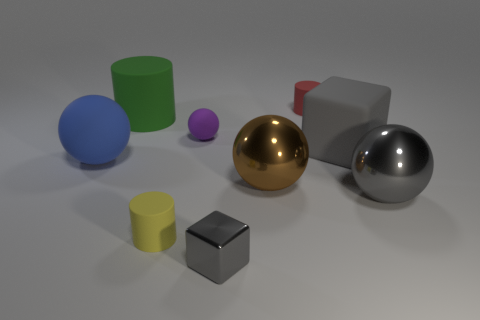Subtract all blue cylinders. Subtract all yellow balls. How many cylinders are left? 3 Subtract all green spheres. How many brown cylinders are left? 0 Add 4 greens. How many purples exist? 0 Subtract all big brown cylinders. Subtract all blue rubber spheres. How many objects are left? 8 Add 5 matte balls. How many matte balls are left? 7 Add 8 metal cubes. How many metal cubes exist? 9 Add 1 large blue rubber things. How many objects exist? 10 Subtract all gray balls. How many balls are left? 3 Subtract all yellow cylinders. How many cylinders are left? 2 Subtract 0 blue blocks. How many objects are left? 9 